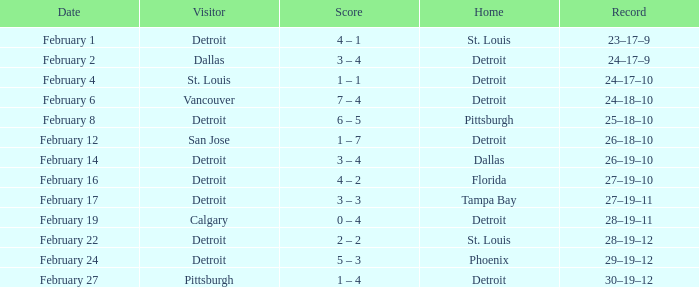What was their accomplishment during their time in pittsburgh? 25–18–10. 